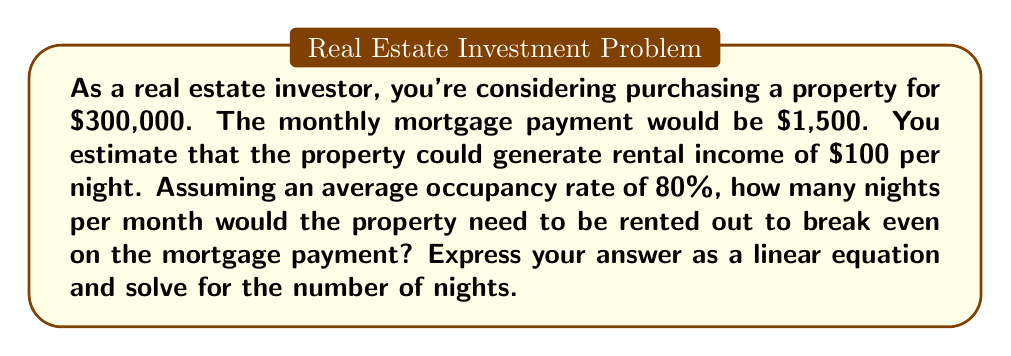Show me your answer to this math problem. Let's approach this step-by-step:

1) Let $x$ be the number of nights the property is rented per month.

2) The monthly rental income can be expressed as:
   $100 \cdot x \cdot 0.80$
   Where $100 is the nightly rate, $x$ is the number of nights, and $0.80$ is the occupancy rate.

3) For the break-even point, the monthly rental income should equal the monthly mortgage payment:

   $100 \cdot x \cdot 0.80 = 1500$

4) This is our linear equation. Let's solve for $x$:

   $80x = 1500$

5) Divide both sides by 80:

   $x = \frac{1500}{80} = 18.75$

6) Since we can't rent for partial nights, we need to round up to the nearest whole number.

Therefore, the property needs to be rented out for 19 nights per month to break even.

The linear equation representing this scenario is:

$$ 80x = 1500 $$

Where $x$ is the number of nights the property needs to be rented.
Answer: 19 nights per month. Linear equation: $80x = 1500$ 